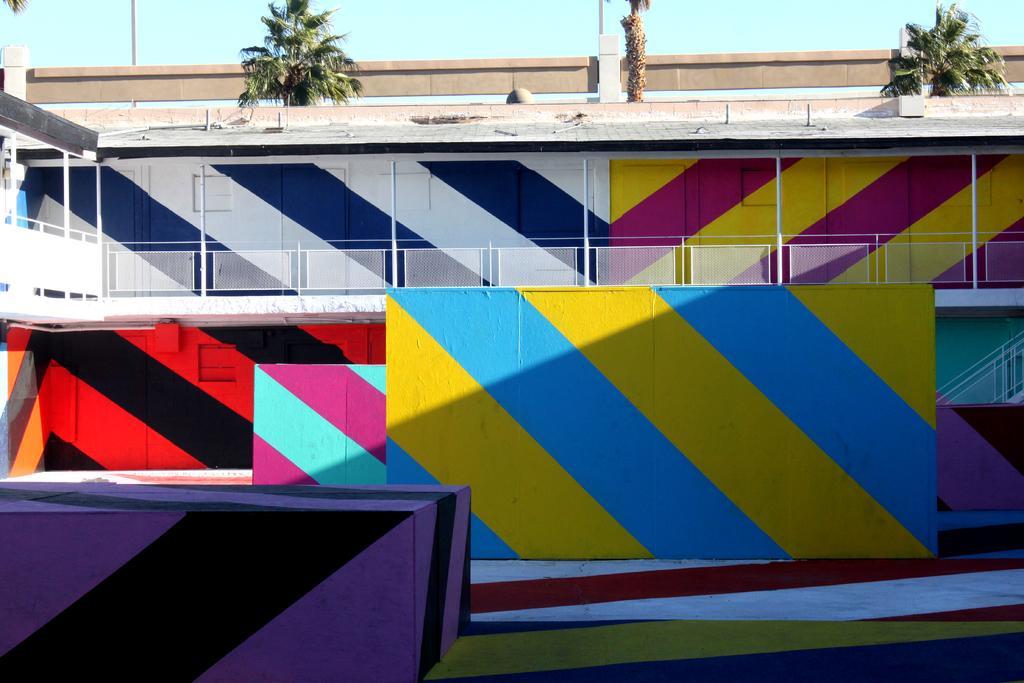Describe this image in one or two sentences. In this image we can see there is a wall with painting and there is a fence, pole, pillar, trees and the sky. 